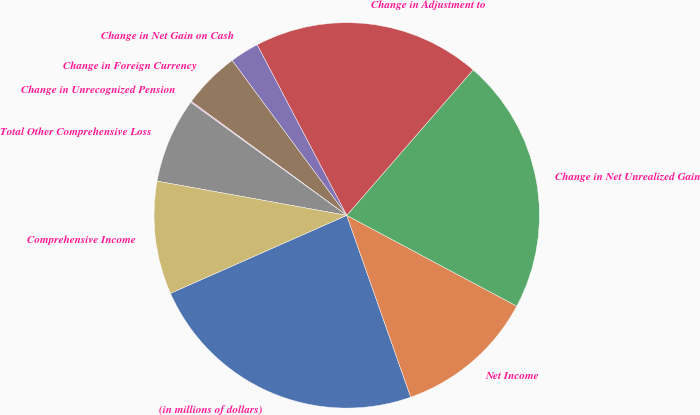Convert chart to OTSL. <chart><loc_0><loc_0><loc_500><loc_500><pie_chart><fcel>(in millions of dollars)<fcel>Net Income<fcel>Change in Net Unrealized Gain<fcel>Change in Adjustment to<fcel>Change in Net Gain on Cash<fcel>Change in Foreign Currency<fcel>Change in Unrecognized Pension<fcel>Total Other Comprehensive Loss<fcel>Comprehensive Income<nl><fcel>23.76%<fcel>11.81%<fcel>21.42%<fcel>19.08%<fcel>2.44%<fcel>4.79%<fcel>0.1%<fcel>7.13%<fcel>9.47%<nl></chart> 